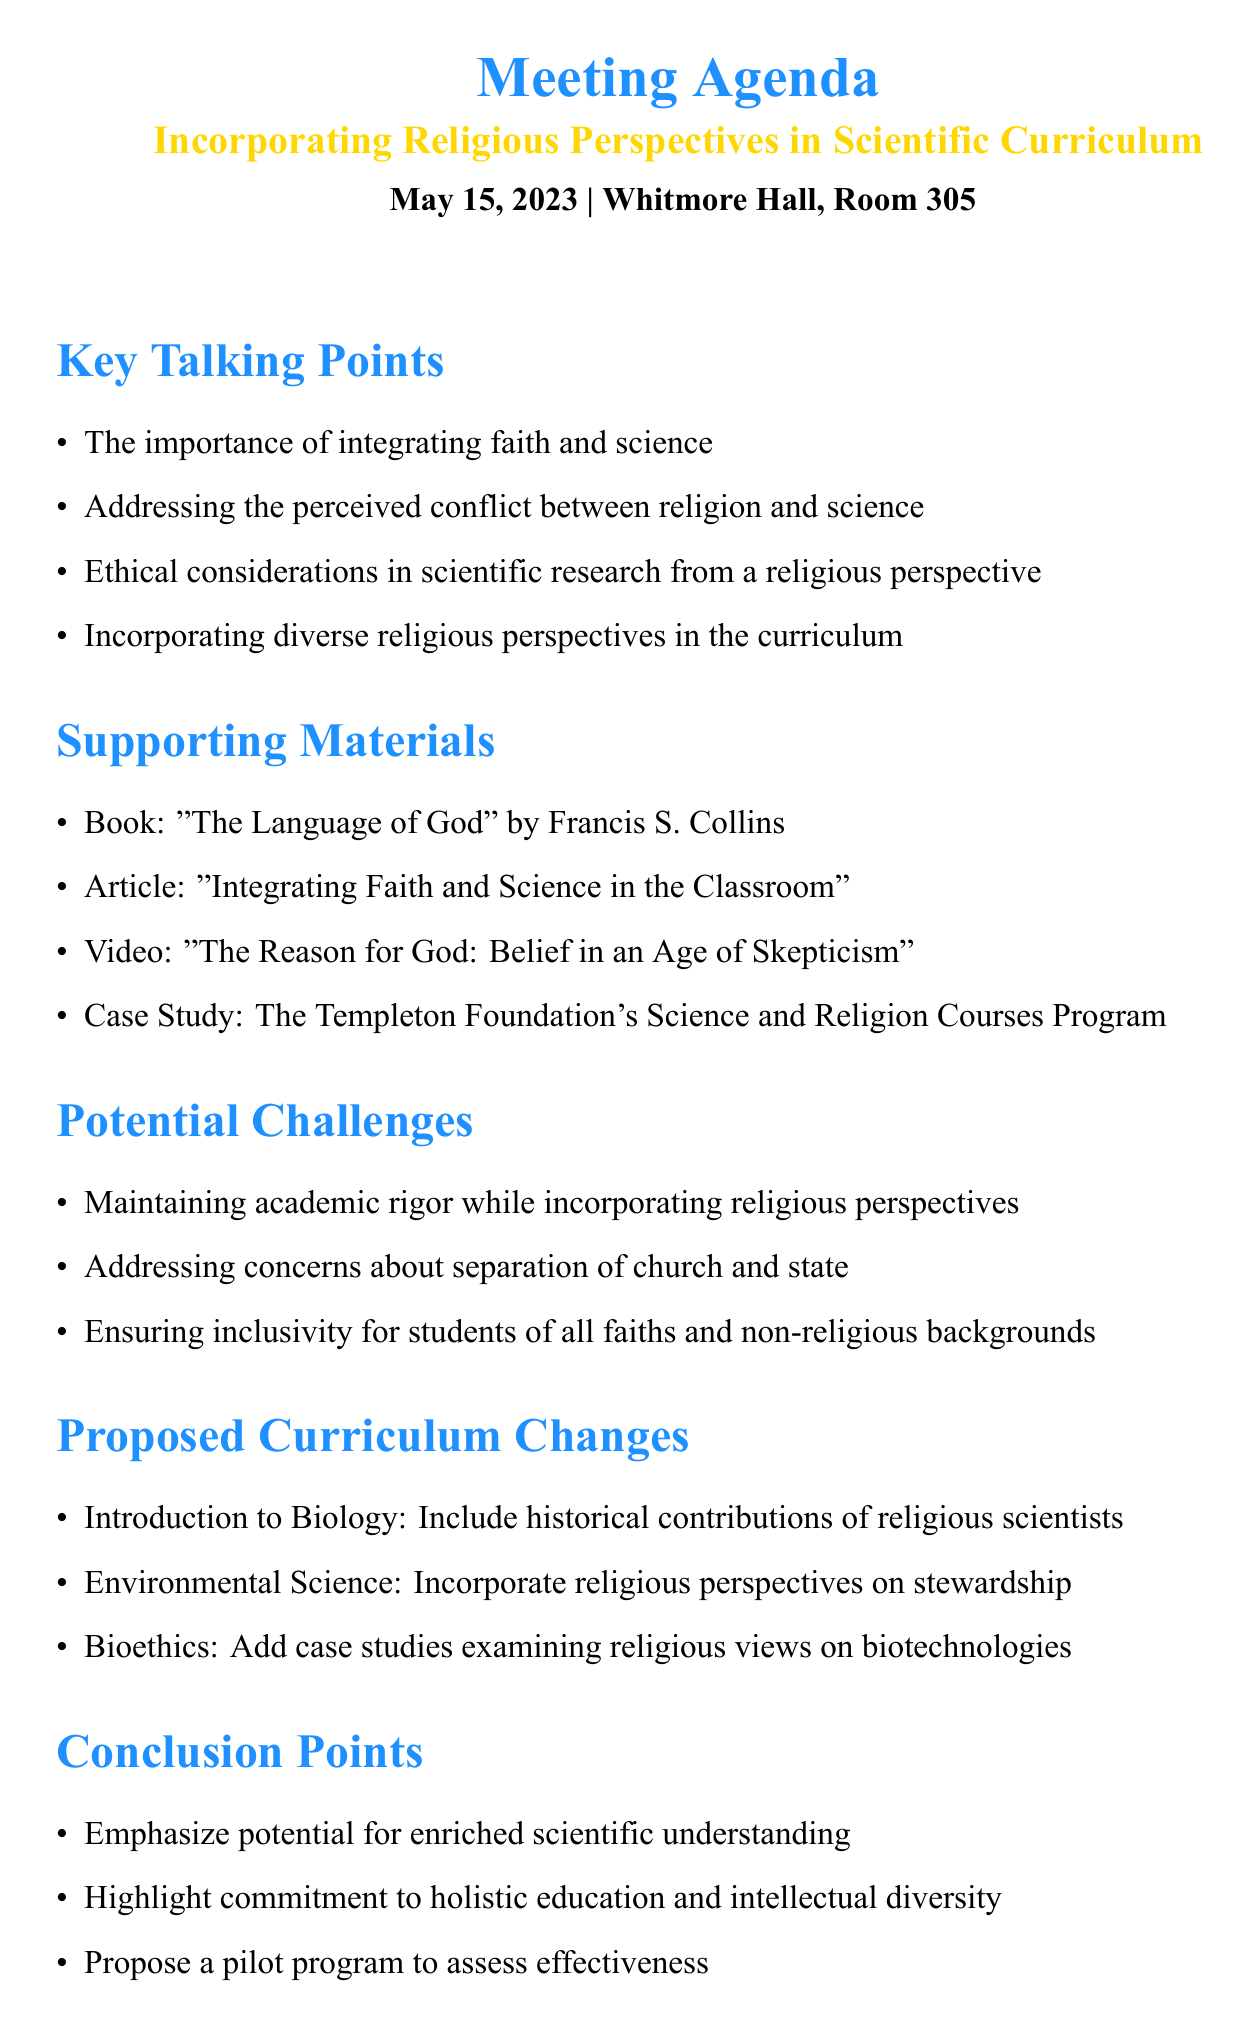What is the meeting date? The meeting date is specified in the agenda, which is May 15, 2023.
Answer: May 15, 2023 Where is the meeting located? The meeting location is provided in the header of the agenda, listed as Whitmore Hall, Room 305.
Answer: Whitmore Hall, Room 305 Who is the author of "The Language of God"? The book "The Language of God" is authored by Francis S. Collins, mentioned in the supporting materials.
Answer: Francis S. Collins What potential challenge addresses concerns about separation of church and state? One potential challenge specified is addressing concerns about separation of church and state in public universities.
Answer: Addressing concerns about separation of church and state What is one proposed change in the Introduction to Biology course? The agenda proposes to include a module on historical contributions of religious scientists to evolutionary theory in the Introduction to Biology course.
Answer: Include a module on historical contributions of religious scientists to evolutionary theory How does the agenda propose to ensure inclusivity in the curriculum? The agenda proposes a comparative approach that includes multiple religious and non-religious perspectives to ensure inclusivity.
Answer: A comparative approach that includes multiple religious and non-religious perspectives What is mentioned as one of the conclusion points? One of the conclusion points emphasizes potential for enriched scientific understanding through diverse perspectives in the curriculum.
Answer: Potential for enriched scientific understanding through diverse perspectives Which article provides practical strategies for incorporating religious perspectives? The article titled "Integrating Faith and Science in the Classroom" offers practical strategies for incorporating religious perspectives in science education.
Answer: "Integrating Faith and Science in the Classroom" 